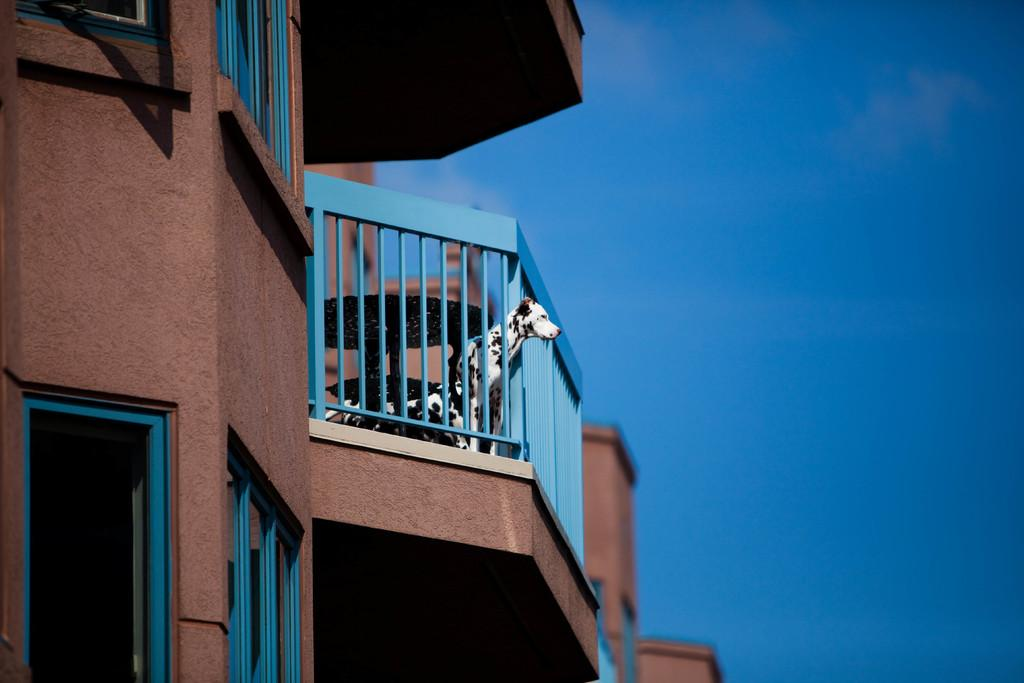What animal can be seen in the image? There is a dog in the image. Where is the dog positioned in the image? The dog is standing at a fence. What type of structures are visible in the image? There are buildings with windows in the image. What can be seen in the background of the image? The sky is visible in the background of the image. How many cakes are on the dog's neck in the image? There are no cakes or necks present in the image; it features a dog standing at a fence. 